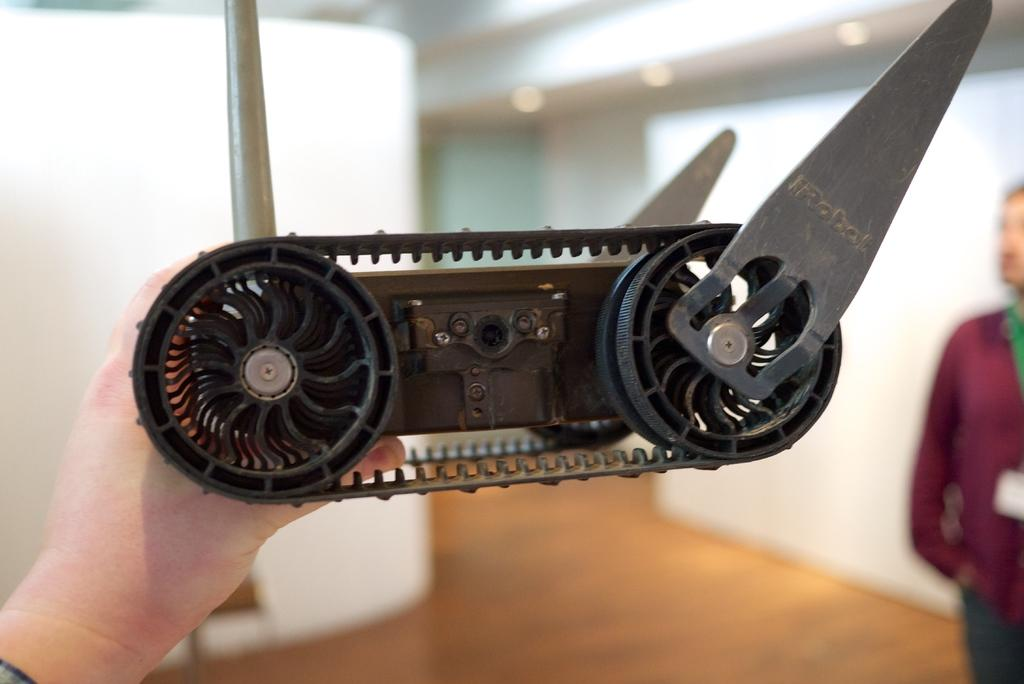What is the main subject of the image? The main subject of the image is a part of a machine. What is the person in the image doing with the machine part? The person is holding the machine part. Can you describe the background of the image? The background of the image is blurred. How many people are visible in the image? There is one person visible on the right side of the image. What type of feeling does the company have towards the machine part in the image? There is no information about a company or any feelings in the image. The image only shows a person holding a machine part and a blurred background. 